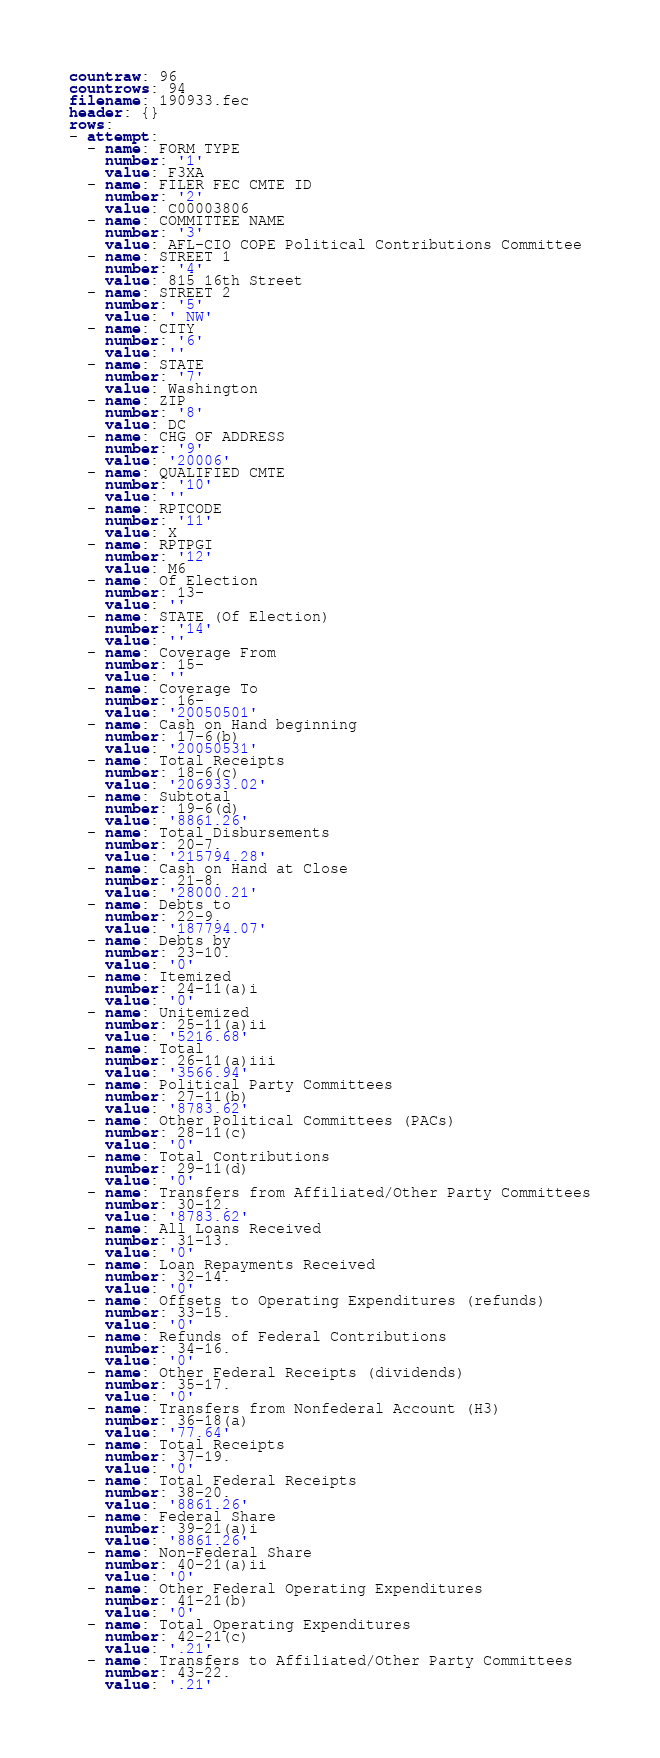Convert code to text. <code><loc_0><loc_0><loc_500><loc_500><_YAML_>countraw: 96
countrows: 94
filename: 190933.fec
header: {}
rows:
- attempt:
  - name: FORM TYPE
    number: '1'
    value: F3XA
  - name: FILER FEC CMTE ID
    number: '2'
    value: C00003806
  - name: COMMITTEE NAME
    number: '3'
    value: AFL-CIO COPE Political Contributions Committee
  - name: STREET 1
    number: '4'
    value: 815 16th Street
  - name: STREET 2
    number: '5'
    value: ' NW'
  - name: CITY
    number: '6'
    value: ''
  - name: STATE
    number: '7'
    value: Washington
  - name: ZIP
    number: '8'
    value: DC
  - name: CHG OF ADDRESS
    number: '9'
    value: '20006'
  - name: QUALIFIED CMTE
    number: '10'
    value: ''
  - name: RPTCODE
    number: '11'
    value: X
  - name: RPTPGI
    number: '12'
    value: M6
  - name: Of Election
    number: 13-
    value: ''
  - name: STATE (Of Election)
    number: '14'
    value: ''
  - name: Coverage From
    number: 15-
    value: ''
  - name: Coverage To
    number: 16-
    value: '20050501'
  - name: Cash on Hand beginning
    number: 17-6(b)
    value: '20050531'
  - name: Total Receipts
    number: 18-6(c)
    value: '206933.02'
  - name: Subtotal
    number: 19-6(d)
    value: '8861.26'
  - name: Total Disbursements
    number: 20-7.
    value: '215794.28'
  - name: Cash on Hand at Close
    number: 21-8.
    value: '28000.21'
  - name: Debts to
    number: 22-9.
    value: '187794.07'
  - name: Debts by
    number: 23-10.
    value: '0'
  - name: Itemized
    number: 24-11(a)i
    value: '0'
  - name: Unitemized
    number: 25-11(a)ii
    value: '5216.68'
  - name: Total
    number: 26-11(a)iii
    value: '3566.94'
  - name: Political Party Committees
    number: 27-11(b)
    value: '8783.62'
  - name: Other Political Committees (PACs)
    number: 28-11(c)
    value: '0'
  - name: Total Contributions
    number: 29-11(d)
    value: '0'
  - name: Transfers from Affiliated/Other Party Committees
    number: 30-12.
    value: '8783.62'
  - name: All Loans Received
    number: 31-13.
    value: '0'
  - name: Loan Repayments Received
    number: 32-14.
    value: '0'
  - name: Offsets to Operating Expenditures (refunds)
    number: 33-15.
    value: '0'
  - name: Refunds of Federal Contributions
    number: 34-16.
    value: '0'
  - name: Other Federal Receipts (dividends)
    number: 35-17.
    value: '0'
  - name: Transfers from Nonfederal Account (H3)
    number: 36-18(a)
    value: '77.64'
  - name: Total Receipts
    number: 37-19.
    value: '0'
  - name: Total Federal Receipts
    number: 38-20.
    value: '8861.26'
  - name: Federal Share
    number: 39-21(a)i
    value: '8861.26'
  - name: Non-Federal Share
    number: 40-21(a)ii
    value: '0'
  - name: Other Federal Operating Expenditures
    number: 41-21(b)
    value: '0'
  - name: Total Operating Expenditures
    number: 42-21(c)
    value: '.21'
  - name: Transfers to Affiliated/Other Party Committees
    number: 43-22.
    value: '.21'</code> 